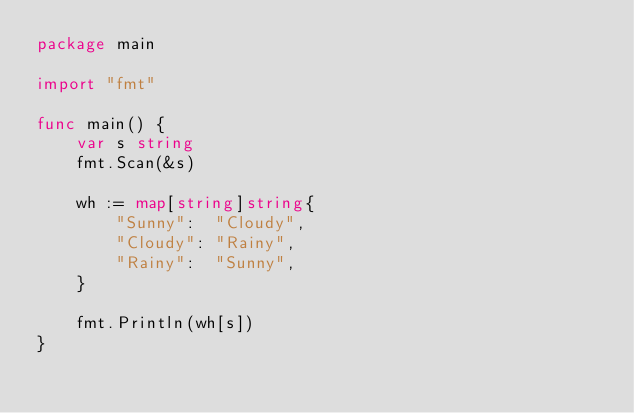Convert code to text. <code><loc_0><loc_0><loc_500><loc_500><_Go_>package main

import "fmt"

func main() {
	var s string
	fmt.Scan(&s)

	wh := map[string]string{
		"Sunny":  "Cloudy",
		"Cloudy": "Rainy",
		"Rainy":  "Sunny",
	}

	fmt.Println(wh[s])
}
</code> 